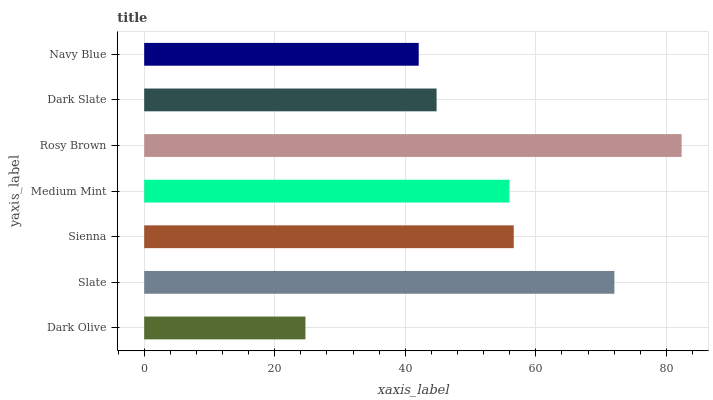Is Dark Olive the minimum?
Answer yes or no. Yes. Is Rosy Brown the maximum?
Answer yes or no. Yes. Is Slate the minimum?
Answer yes or no. No. Is Slate the maximum?
Answer yes or no. No. Is Slate greater than Dark Olive?
Answer yes or no. Yes. Is Dark Olive less than Slate?
Answer yes or no. Yes. Is Dark Olive greater than Slate?
Answer yes or no. No. Is Slate less than Dark Olive?
Answer yes or no. No. Is Medium Mint the high median?
Answer yes or no. Yes. Is Medium Mint the low median?
Answer yes or no. Yes. Is Sienna the high median?
Answer yes or no. No. Is Sienna the low median?
Answer yes or no. No. 